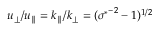Convert formula to latex. <formula><loc_0><loc_0><loc_500><loc_500>u _ { \perp } / u _ { \| } = k _ { \| } / k _ { \perp } = ( { \sigma ^ { * } } ^ { - 2 } - 1 ) ^ { 1 / 2 }</formula> 